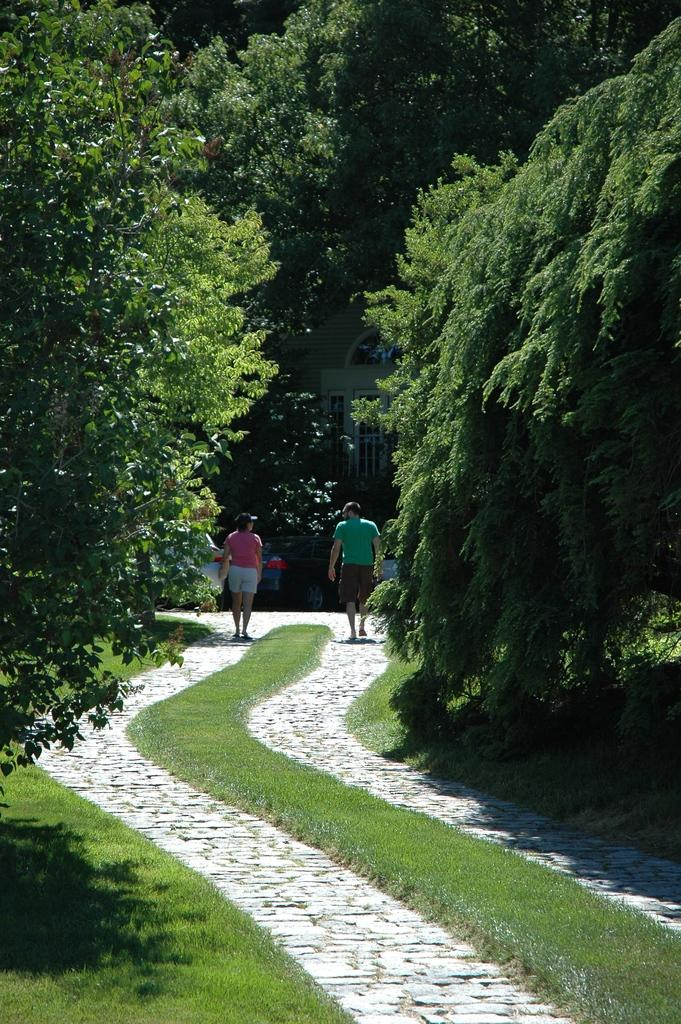What are the two persons in the image doing? The two persons in the image are walking. Can you describe the path they are walking on? The path they are walking on has grass in the middle. What type of vegetation is present on the grassland? There are trees on the grassland. Are there any other people in the image besides the two walking? Yes, there are additional persons in the image. What can be seen in the background of the image? There is a building visible in the background. What type of hate can be seen between the two brothers in the image? There is no mention of brothers or hate in the image. The image features two persons walking, and there is no indication of any negative emotions or relationships between them. 